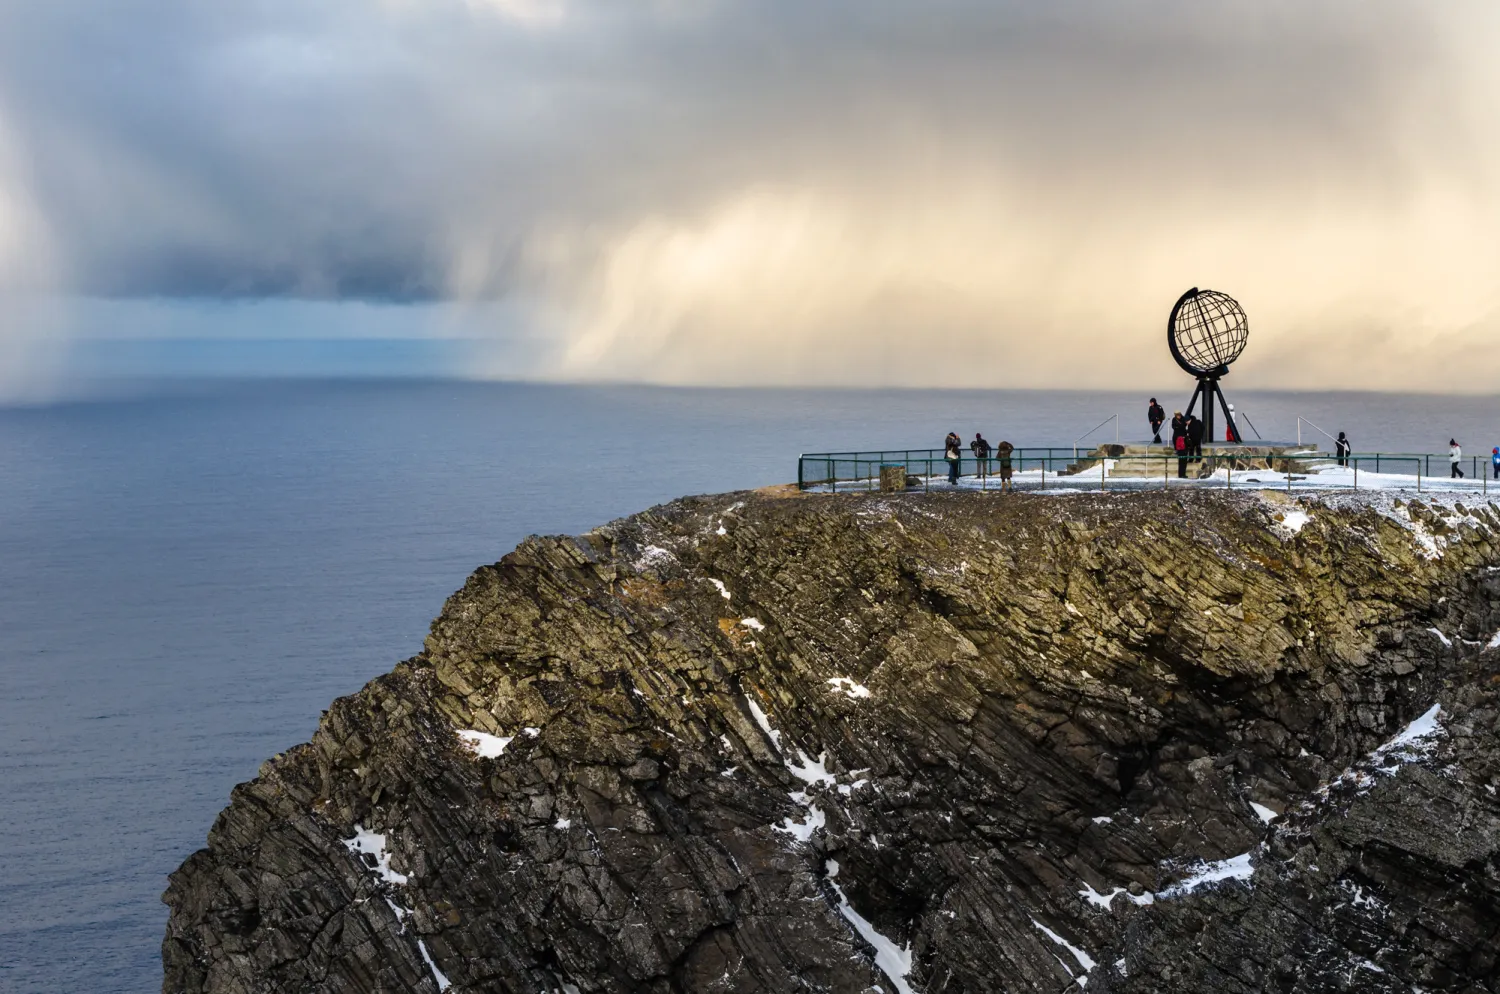What is the significance of the metal globe sculpture in this image? The metal globe sculpture at North Cape, often referred to as a 'globus', serves as a symbolic marker representing the northernmost point of Europe accessible by road. It is a powerful symbol of journey and destination, attracting tourists who view reaching it as a significant achievement. The sculpture emphasizes the remote and unique position of North Cape, offering a tangible connection to the concept of global geography. 